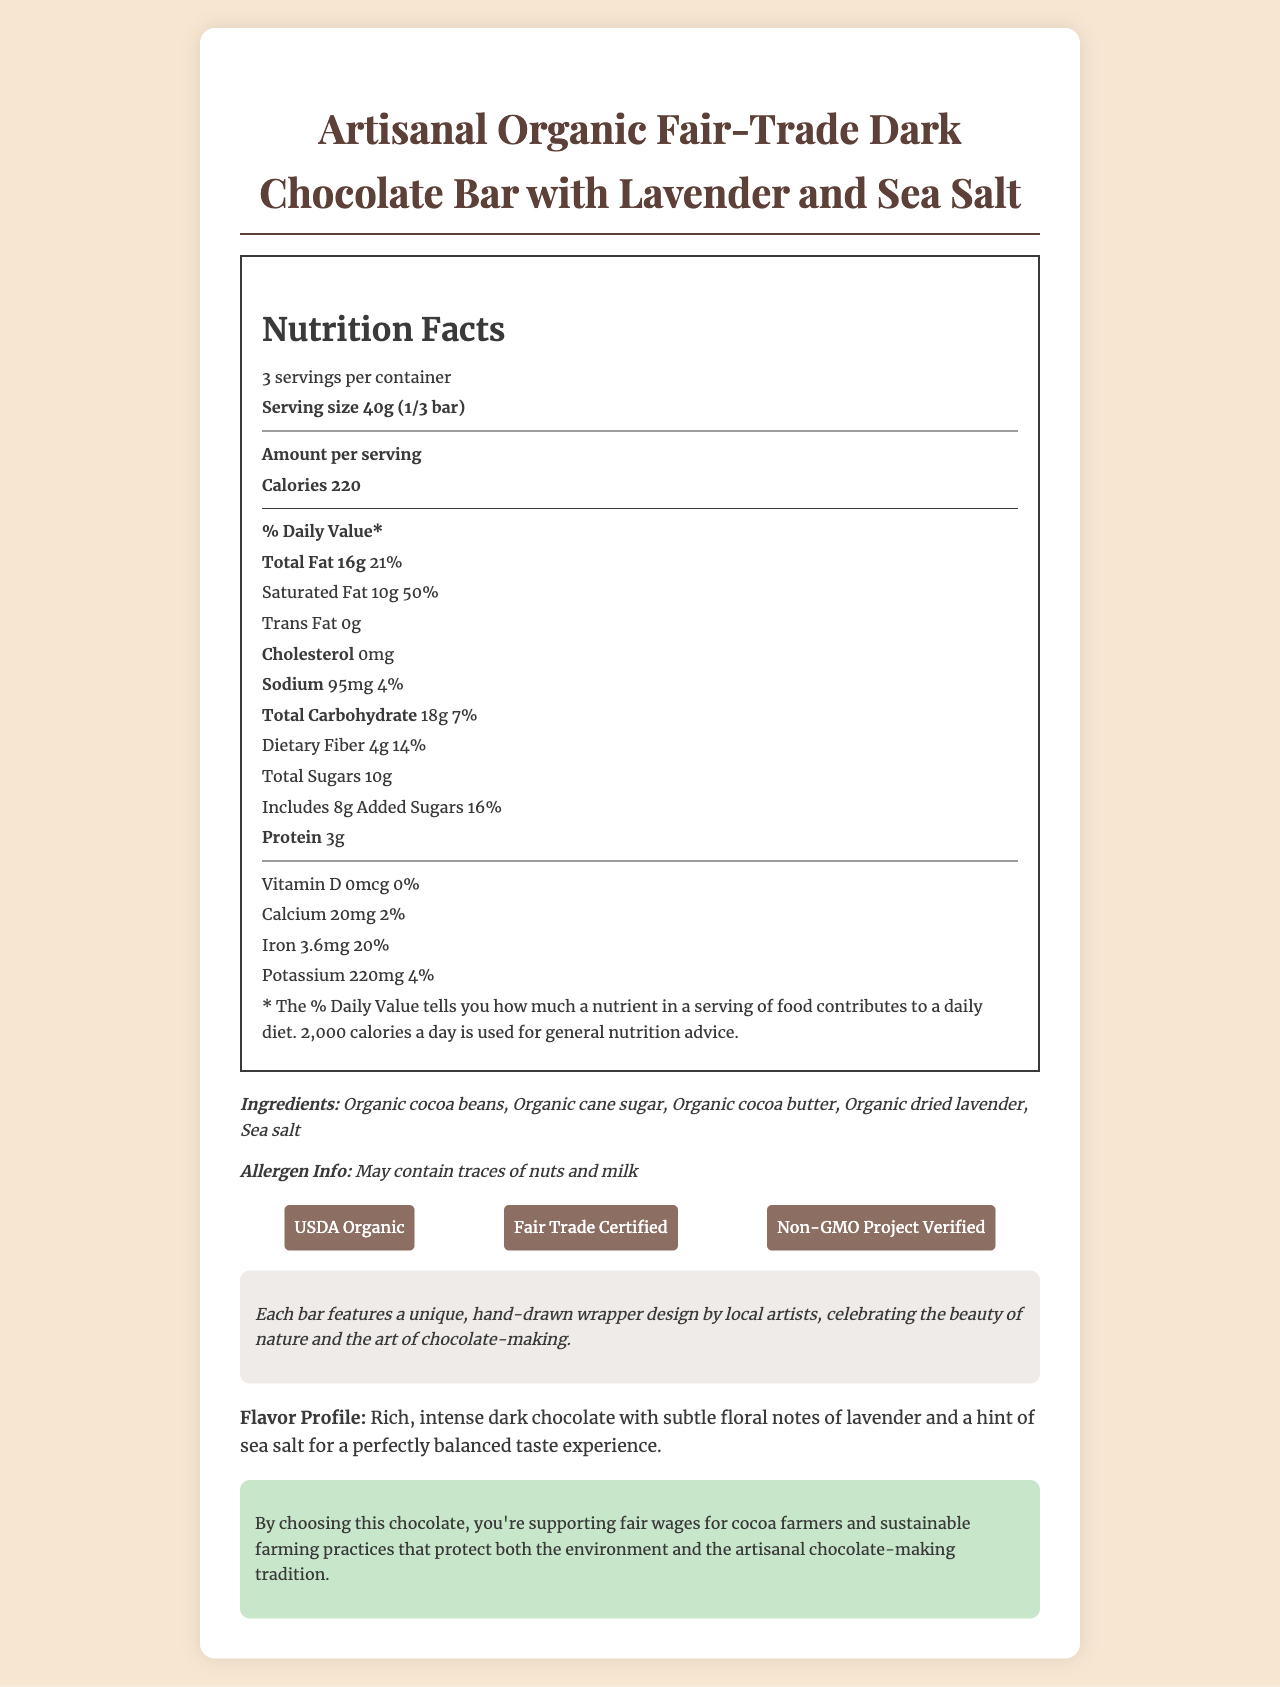what is the serving size? The serving size is clearly stated in the nutrition facts section at the top of the document as "Serving size 40g (1/3 bar)".
Answer: 40g (1/3 bar) how many servings are there per container? The document lists the number of servings per container as 3.
Answer: 3 what are the ingredients of this chocolate bar? The ingredients are listed under the ingredients section.
Answer: Organic cocoa beans, Organic cane sugar, Organic cocoa butter, Organic dried lavender, Sea salt what certifications does this chocolate have? The certifications are listed in the certifications section with their respective logos.
Answer: USDA Organic, Fair Trade Certified, Non-GMO Project Verified how much dietary fiber is in one serving? The amount of dietary fiber per serving is listed as "Dietary Fiber 4g".
Answer: 4g what is the cocoa content of the chocolate? The cocoa content is stated in the additional information section under "cocoa content".
Answer: 72% what is the daily value percentage of calcium in one serving? A. 2% B. 5% C. 10% D. 20% The daily value percentage of calcium in one serving is listed as 2% in the nutrition facts section.
Answer: A. 2% which of the following does this chocolate NOT contain? I. Gluten II. Nuts III. Milk The document notes that the chocolate is gluten-free and vegan, but it does mention that it may contain traces of nuts and milk.
Answer: II. Nuts is the packaging of this chocolate bar eco-friendly? The packaging is mentioned as eco-friendly and biodegradable in the additional information section.
Answer: Yes does this chocolate bar contain any trans fat? The nutrition facts state that there are 0g of trans fat per serving.
Answer: No summarize the main idea of the document. The summary covers all the major sections of the document, including nutrition facts, ingredients, certifications, additional information, and the ethical statement.
Answer: The document provides detailed information about the nutrition facts, ingredients, certifications, and additional features of the Artisanal Organic Fair-Trade Dark Chocolate Bar with Lavender and Sea Salt. It highlights the bar's 72% cocoa content, organic and fair-trade certifications, unique flavor profile, and eco-friendly packaging. The document also emphasizes ethical statements about supporting fair wages for farmers and sustainable practices. where is this chocolate manufactured? The document does not provide any information about the location of the chocolate's manufacturing.
Answer: I don't know 